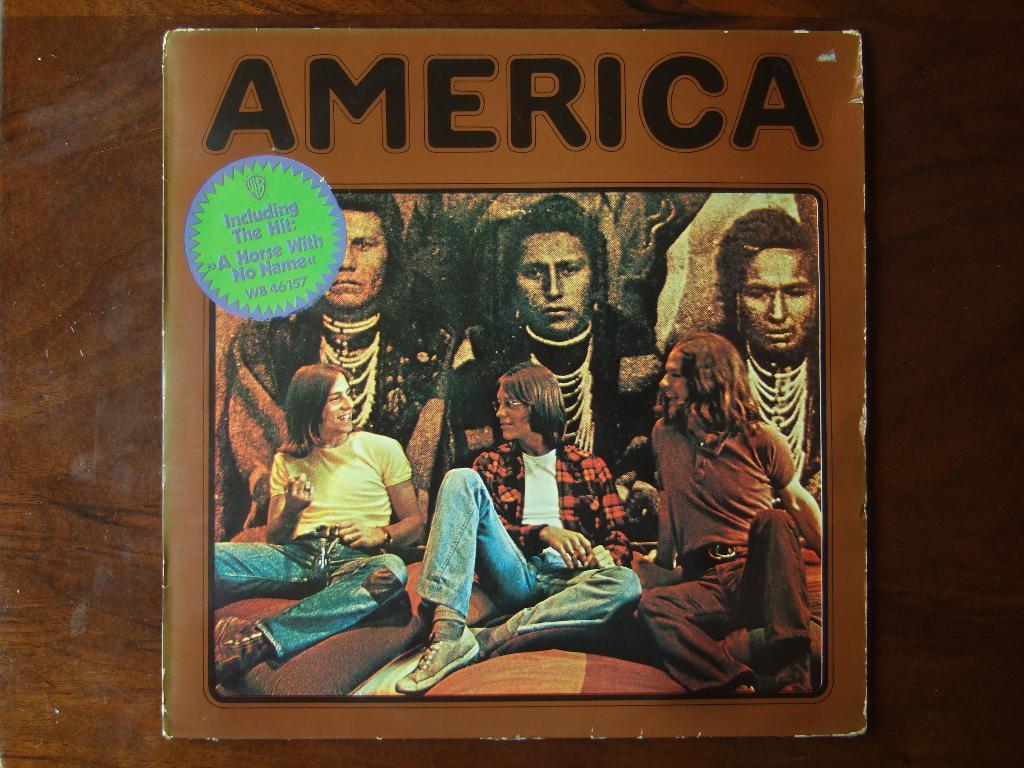What is the name of this album?
Provide a short and direct response. America. What is included in this hit?
Make the answer very short. A horse with no name. 